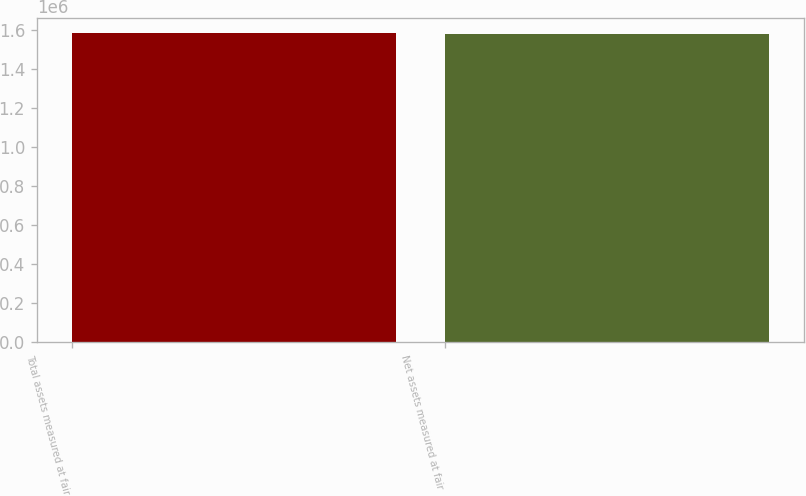Convert chart. <chart><loc_0><loc_0><loc_500><loc_500><bar_chart><fcel>Total assets measured at fair<fcel>Net assets measured at fair<nl><fcel>1.58373e+06<fcel>1.58054e+06<nl></chart> 